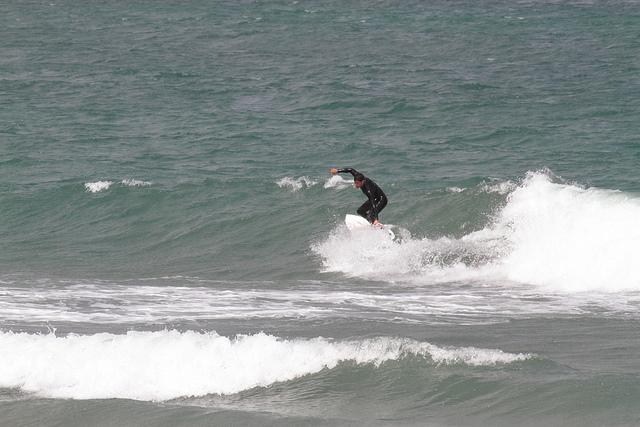What color is the man's wetsuit?
Keep it brief. Black. Is this a man or a woman surfing?
Short answer required. Man. What color is the man's bored?
Answer briefly. White. What is the man doing?
Quick response, please. Surfing. 